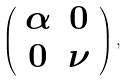<formula> <loc_0><loc_0><loc_500><loc_500>\left ( \begin{array} { c c } \alpha & 0 \\ 0 & \nu \\ \end{array} \right ) ,</formula> 